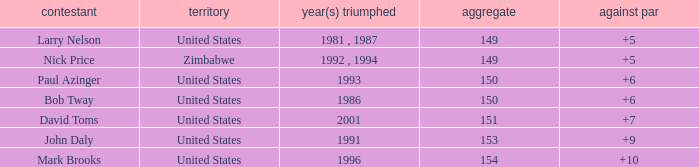How many to pars were won in 1993? 1.0. 